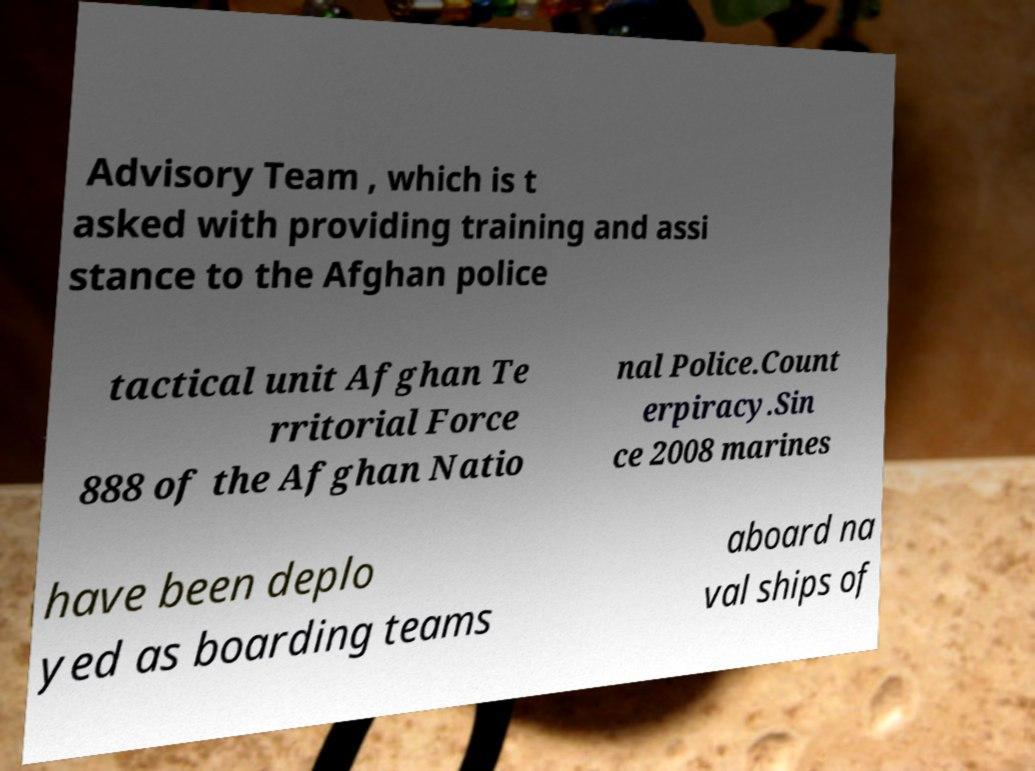I need the written content from this picture converted into text. Can you do that? Advisory Team , which is t asked with providing training and assi stance to the Afghan police tactical unit Afghan Te rritorial Force 888 of the Afghan Natio nal Police.Count erpiracy.Sin ce 2008 marines have been deplo yed as boarding teams aboard na val ships of 